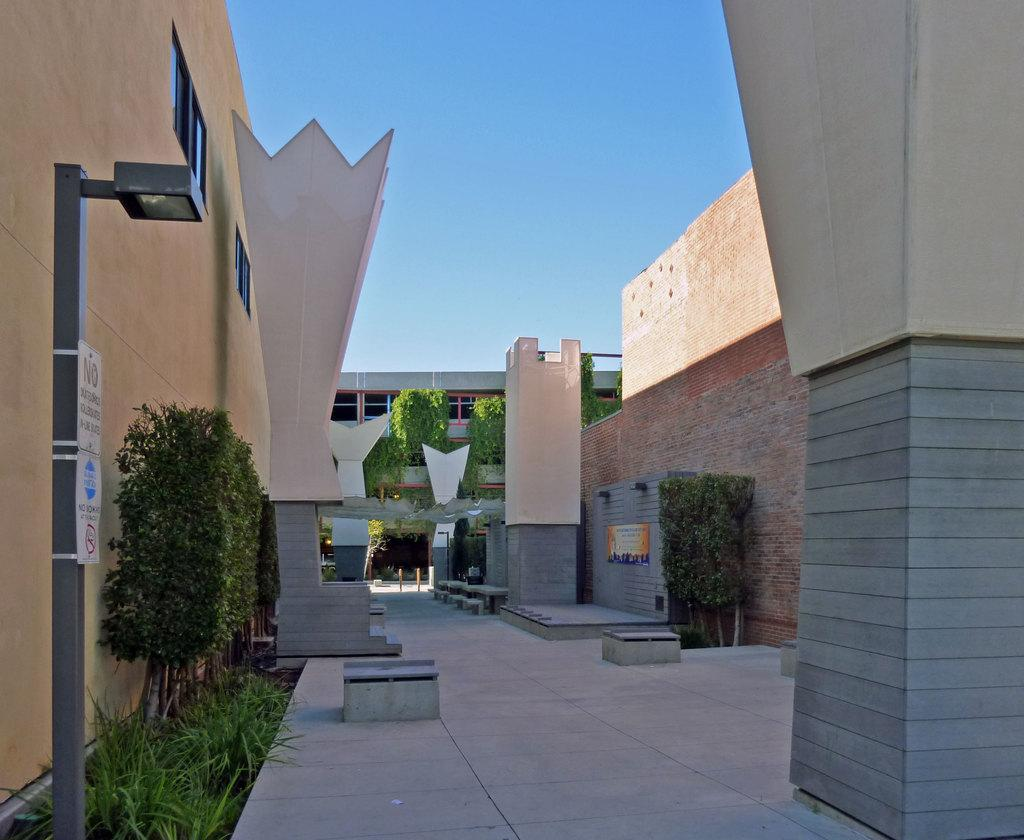<image>
Provide a brief description of the given image. the word no is on a white sign outside 